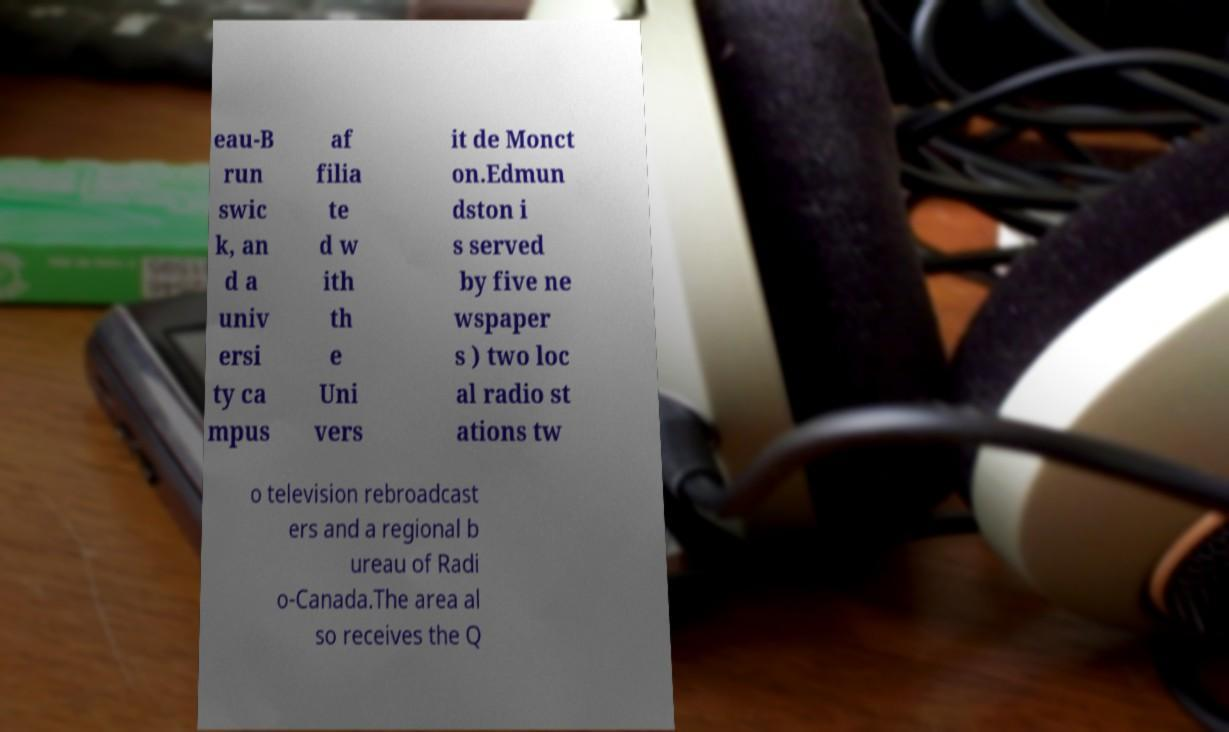Could you assist in decoding the text presented in this image and type it out clearly? eau-B run swic k, an d a univ ersi ty ca mpus af filia te d w ith th e Uni vers it de Monct on.Edmun dston i s served by five ne wspaper s ) two loc al radio st ations tw o television rebroadcast ers and a regional b ureau of Radi o-Canada.The area al so receives the Q 